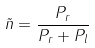<formula> <loc_0><loc_0><loc_500><loc_500>\tilde { n } = \frac { P _ { r } } { P _ { r } + P _ { l } }</formula> 